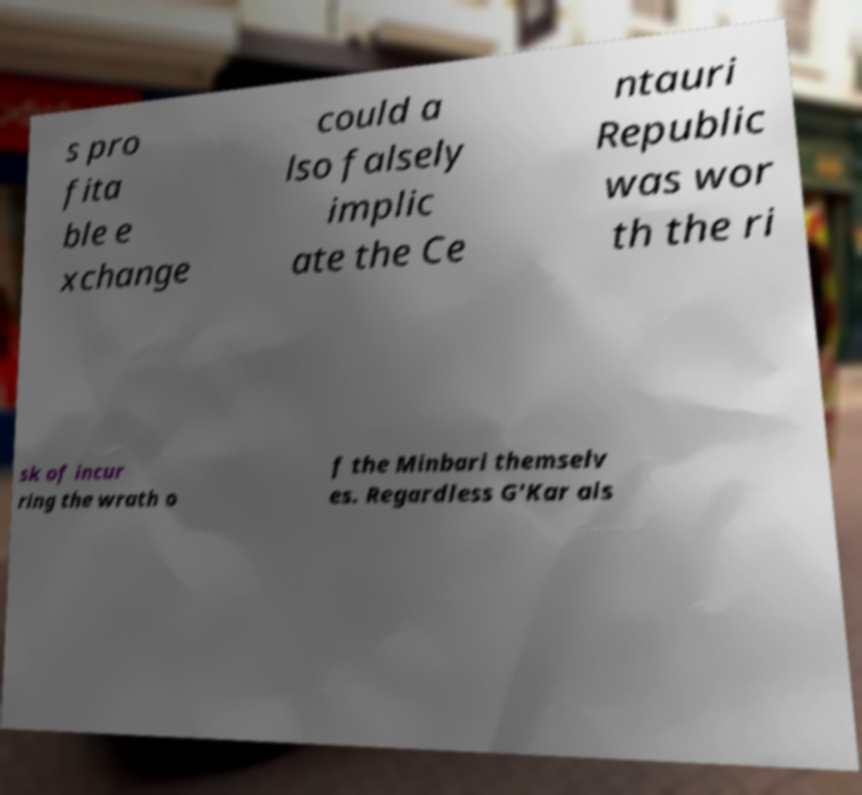What messages or text are displayed in this image? I need them in a readable, typed format. s pro fita ble e xchange could a lso falsely implic ate the Ce ntauri Republic was wor th the ri sk of incur ring the wrath o f the Minbari themselv es. Regardless G'Kar als 